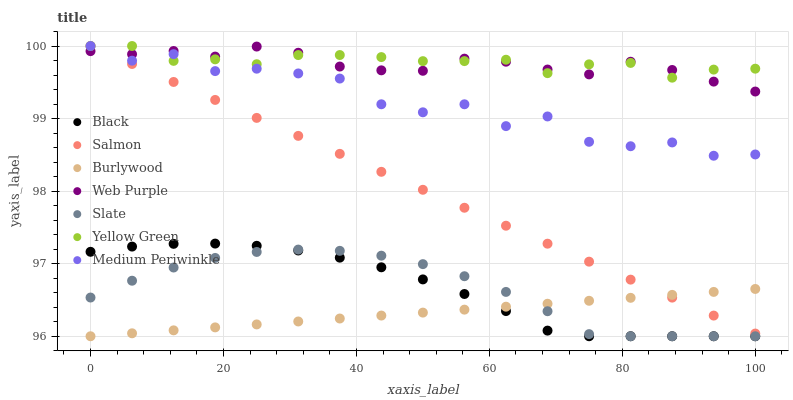Does Burlywood have the minimum area under the curve?
Answer yes or no. Yes. Does Yellow Green have the maximum area under the curve?
Answer yes or no. Yes. Does Medium Periwinkle have the minimum area under the curve?
Answer yes or no. No. Does Medium Periwinkle have the maximum area under the curve?
Answer yes or no. No. Is Burlywood the smoothest?
Answer yes or no. Yes. Is Medium Periwinkle the roughest?
Answer yes or no. Yes. Is Medium Periwinkle the smoothest?
Answer yes or no. No. Is Burlywood the roughest?
Answer yes or no. No. Does Burlywood have the lowest value?
Answer yes or no. Yes. Does Medium Periwinkle have the lowest value?
Answer yes or no. No. Does Salmon have the highest value?
Answer yes or no. Yes. Does Burlywood have the highest value?
Answer yes or no. No. Is Burlywood less than Yellow Green?
Answer yes or no. Yes. Is Yellow Green greater than Burlywood?
Answer yes or no. Yes. Does Yellow Green intersect Medium Periwinkle?
Answer yes or no. Yes. Is Yellow Green less than Medium Periwinkle?
Answer yes or no. No. Is Yellow Green greater than Medium Periwinkle?
Answer yes or no. No. Does Burlywood intersect Yellow Green?
Answer yes or no. No. 